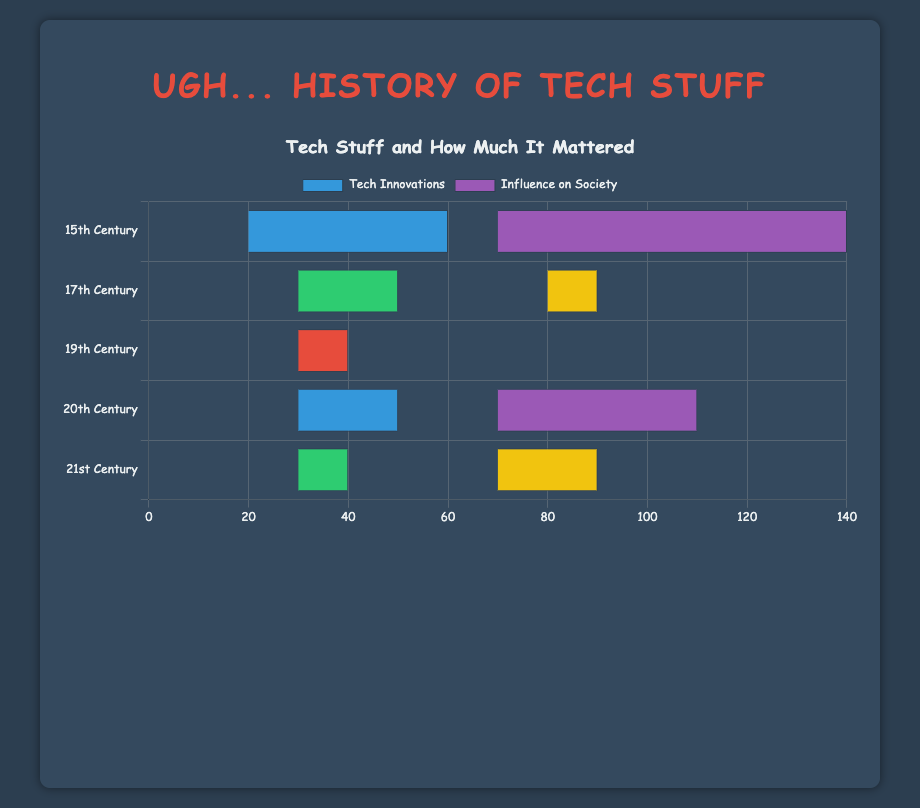Which century had the highest influence of the Printing Press on society and what was the percentage? To find this, look at the '15th Century' bar for the 'Printing Press' section. The chart indicates the Printing Press had an influence of 80% as shown by the length of the corresponding bar.
Answer: 15th Century, 80% In the 19th Century, which technological innovation had the lowest societal influence? Look at the bars for the 19th Century and identify the smallest segment. The Telephone has the shortest bar segment in the influence section, showing a 20% influence.
Answer: Telephone Compare the influence on society of the Internet in the 20th Century with that of smartphones in the 21st Century. Which had a greater influence and by how much? The Internet in the 20th Century had a 60% influence, while smartphones in the 21st Century had a 50% influence. The Internet had a 10% greater influence.
Answer: The Internet, by 10% What is the total percentage influence on society for all innovations combined in the 17th Century? Sum the influence percentages for the Telescope (40%), Steam Engine (30%), and Microscope (30%) in the 17th Century, which results in 40 + 30 + 30 = 100%.
Answer: 100% Between the Steam Engine and the Electricty, which had a higher influence on society in their respective centuries and what were their influences? The Steam Engine in the 17th Century had a 30% influence, while the Electricty in the 19th Century had a 40% influence. Electricty had a higher influence by 10%.
Answer: Electricity, 40% What is the average influence on society for the Telescope and the Microscope in the 17th Century? Combine the influences: 40% for the Telescope and 30% for the Microscope, then divide by 2: (40 + 30) / 2 = 35%.
Answer: 35% Compare the technological innovations in the 21st Century: Which had the same percentage influence on society as its technological innovation percentage, and what was that percentage? Look at the 21st Century bars for both technological innovation and influence. Renewable Energy had a 30% influence, which matches its technological innovation percentage.
Answer: Renewable Energy, 30% What is the difference in influence on society between the Mariner's Astrolabe and the Portable Watch in the 15th Century? The Mariner's Astrolabe and the Portable Watch both had 10% influence, so the difference is 0%.
Answer: 0% 